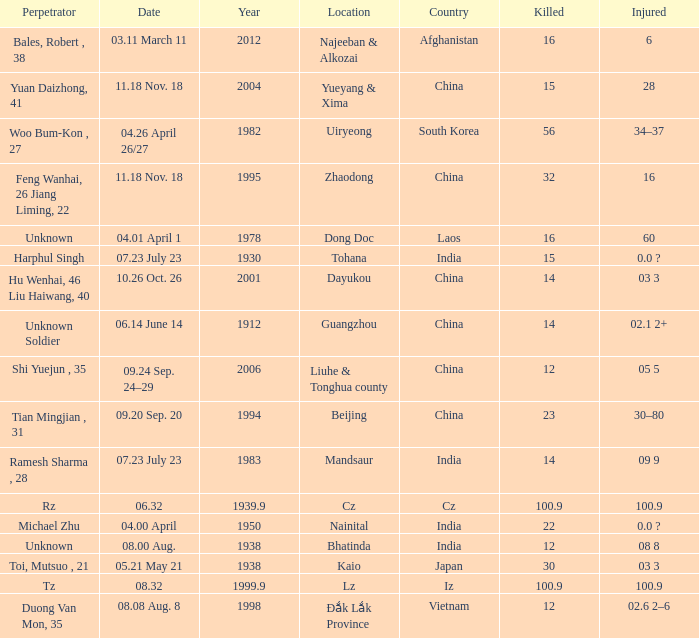What is Country, when Killed is "100.9", and when Year is greater than 1939.9? Iz. 